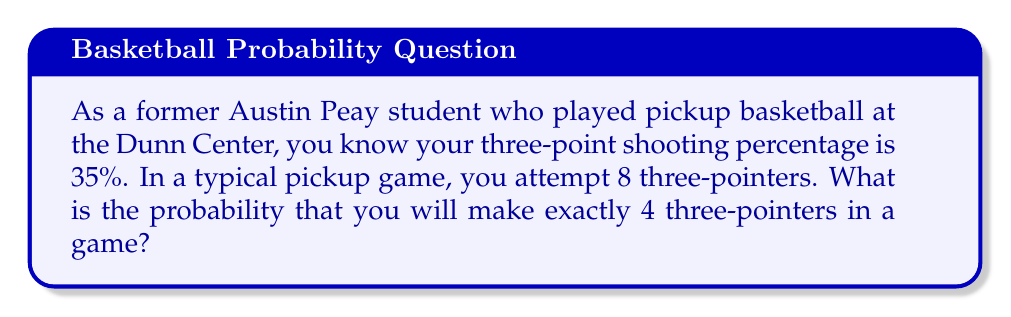Teach me how to tackle this problem. Let's approach this step-by-step:

1) This scenario follows a binomial distribution. We have:
   - $n = 8$ (number of attempts)
   - $p = 0.35$ (probability of success on each attempt)
   - $k = 4$ (number of successes we're interested in)

2) The probability mass function for a binomial distribution is:

   $$ P(X = k) = \binom{n}{k} p^k (1-p)^{n-k} $$

3) Let's calculate each part:
   
   a) $\binom{n}{k} = \binom{8}{4} = \frac{8!}{4!(8-4)!} = 70$
   
   b) $p^k = 0.35^4 \approx 0.0150$
   
   c) $(1-p)^{n-k} = 0.65^4 \approx 0.1785$

4) Now, let's put it all together:

   $$ P(X = 4) = 70 \cdot 0.0150 \cdot 0.1785 \approx 0.1873 $$

5) Therefore, the probability of making exactly 4 three-pointers out of 8 attempts is approximately 0.1873 or 18.73%.
Answer: 0.1873 